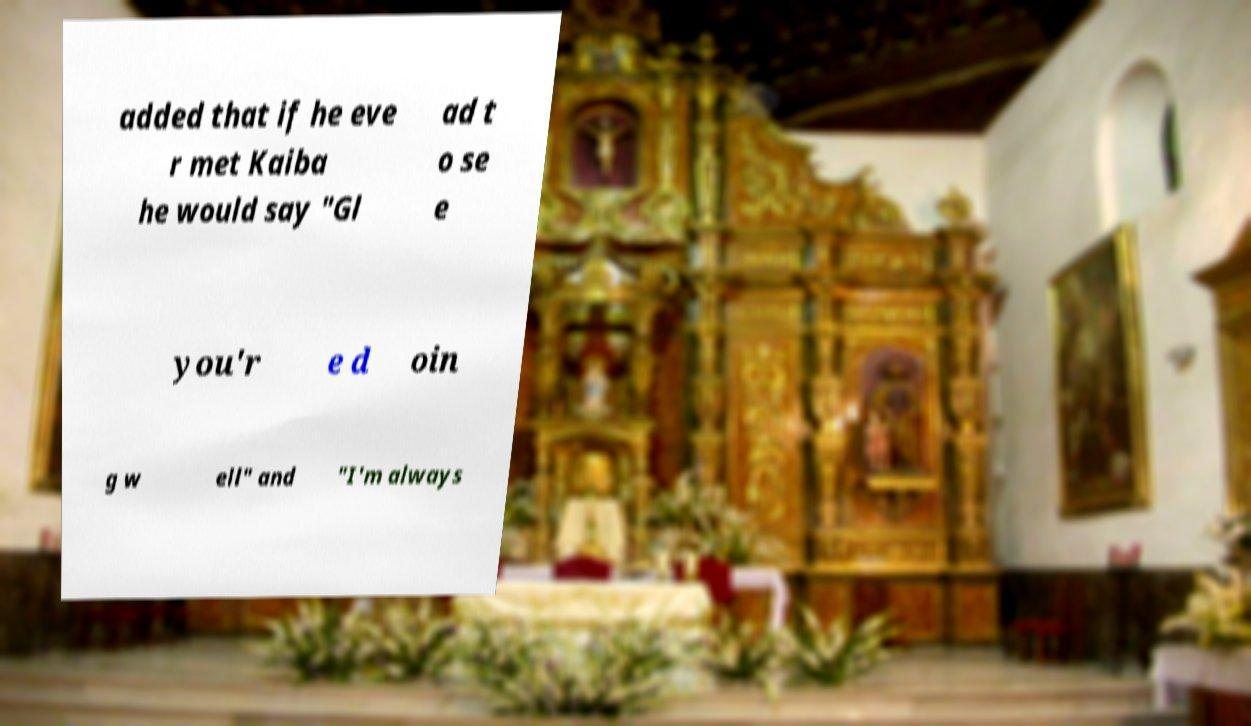Could you assist in decoding the text presented in this image and type it out clearly? added that if he eve r met Kaiba he would say "Gl ad t o se e you'r e d oin g w ell" and "I'm always 